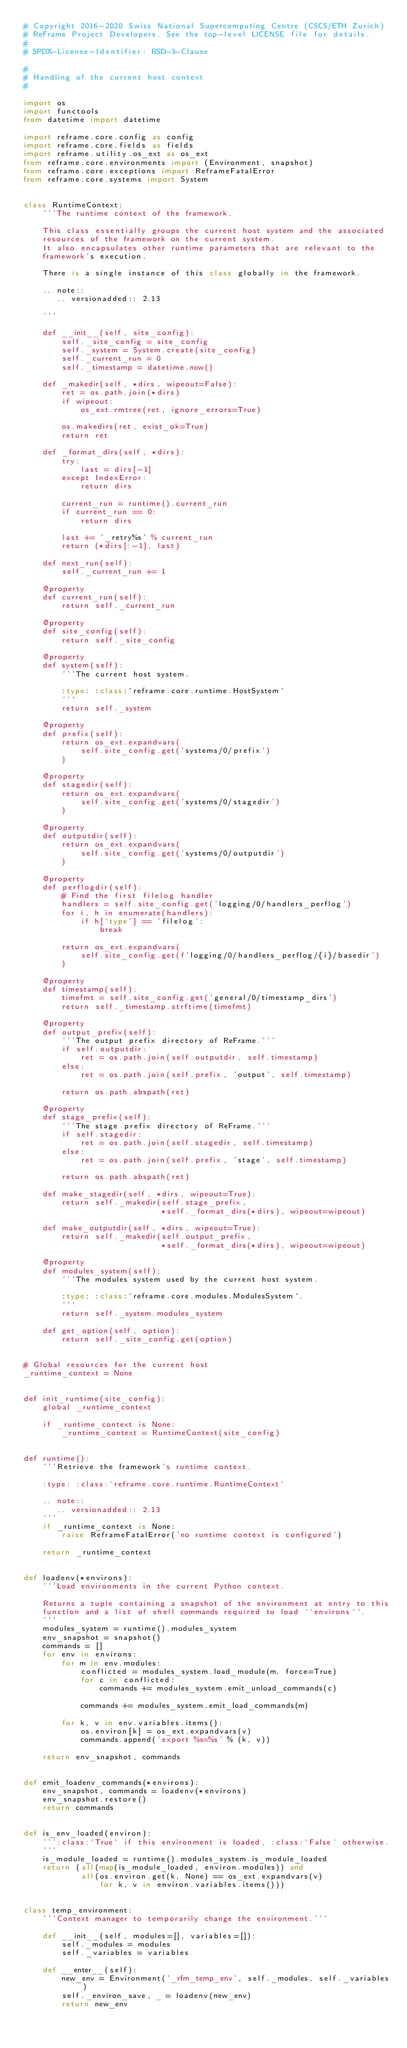<code> <loc_0><loc_0><loc_500><loc_500><_Python_># Copyright 2016-2020 Swiss National Supercomputing Centre (CSCS/ETH Zurich)
# ReFrame Project Developers. See the top-level LICENSE file for details.
#
# SPDX-License-Identifier: BSD-3-Clause

#
# Handling of the current host context
#

import os
import functools
from datetime import datetime

import reframe.core.config as config
import reframe.core.fields as fields
import reframe.utility.os_ext as os_ext
from reframe.core.environments import (Environment, snapshot)
from reframe.core.exceptions import ReframeFatalError
from reframe.core.systems import System


class RuntimeContext:
    '''The runtime context of the framework.

    This class essentially groups the current host system and the associated
    resources of the framework on the current system.
    It also encapsulates other runtime parameters that are relevant to the
    framework's execution.

    There is a single instance of this class globally in the framework.

    .. note::
       .. versionadded:: 2.13

    '''

    def __init__(self, site_config):
        self._site_config = site_config
        self._system = System.create(site_config)
        self._current_run = 0
        self._timestamp = datetime.now()

    def _makedir(self, *dirs, wipeout=False):
        ret = os.path.join(*dirs)
        if wipeout:
            os_ext.rmtree(ret, ignore_errors=True)

        os.makedirs(ret, exist_ok=True)
        return ret

    def _format_dirs(self, *dirs):
        try:
            last = dirs[-1]
        except IndexError:
            return dirs

        current_run = runtime().current_run
        if current_run == 0:
            return dirs

        last += '_retry%s' % current_run
        return (*dirs[:-1], last)

    def next_run(self):
        self._current_run += 1

    @property
    def current_run(self):
        return self._current_run

    @property
    def site_config(self):
        return self._site_config

    @property
    def system(self):
        '''The current host system.

        :type: :class:`reframe.core.runtime.HostSystem`
        '''
        return self._system

    @property
    def prefix(self):
        return os_ext.expandvars(
            self.site_config.get('systems/0/prefix')
        )

    @property
    def stagedir(self):
        return os_ext.expandvars(
            self.site_config.get('systems/0/stagedir')
        )

    @property
    def outputdir(self):
        return os_ext.expandvars(
            self.site_config.get('systems/0/outputdir')
        )

    @property
    def perflogdir(self):
        # Find the first filelog handler
        handlers = self.site_config.get('logging/0/handlers_perflog')
        for i, h in enumerate(handlers):
            if h['type'] == 'filelog':
                break

        return os_ext.expandvars(
            self.site_config.get(f'logging/0/handlers_perflog/{i}/basedir')
        )

    @property
    def timestamp(self):
        timefmt = self.site_config.get('general/0/timestamp_dirs')
        return self._timestamp.strftime(timefmt)

    @property
    def output_prefix(self):
        '''The output prefix directory of ReFrame.'''
        if self.outputdir:
            ret = os.path.join(self.outputdir, self.timestamp)
        else:
            ret = os.path.join(self.prefix, 'output', self.timestamp)

        return os.path.abspath(ret)

    @property
    def stage_prefix(self):
        '''The stage prefix directory of ReFrame.'''
        if self.stagedir:
            ret = os.path.join(self.stagedir, self.timestamp)
        else:
            ret = os.path.join(self.prefix, 'stage', self.timestamp)

        return os.path.abspath(ret)

    def make_stagedir(self, *dirs, wipeout=True):
        return self._makedir(self.stage_prefix,
                             *self._format_dirs(*dirs), wipeout=wipeout)

    def make_outputdir(self, *dirs, wipeout=True):
        return self._makedir(self.output_prefix,
                             *self._format_dirs(*dirs), wipeout=wipeout)

    @property
    def modules_system(self):
        '''The modules system used by the current host system.

        :type: :class:`reframe.core.modules.ModulesSystem`.
        '''
        return self._system.modules_system

    def get_option(self, option):
        return self._site_config.get(option)


# Global resources for the current host
_runtime_context = None


def init_runtime(site_config):
    global _runtime_context

    if _runtime_context is None:
        _runtime_context = RuntimeContext(site_config)


def runtime():
    '''Retrieve the framework's runtime context.

    :type: :class:`reframe.core.runtime.RuntimeContext`

    .. note::
       .. versionadded:: 2.13
    '''
    if _runtime_context is None:
        raise ReframeFatalError('no runtime context is configured')

    return _runtime_context


def loadenv(*environs):
    '''Load environments in the current Python context.

    Returns a tuple containing a snapshot of the environment at entry to this
    function and a list of shell commands required to load ``environs``.
    '''
    modules_system = runtime().modules_system
    env_snapshot = snapshot()
    commands = []
    for env in environs:
        for m in env.modules:
            conflicted = modules_system.load_module(m, force=True)
            for c in conflicted:
                commands += modules_system.emit_unload_commands(c)

            commands += modules_system.emit_load_commands(m)

        for k, v in env.variables.items():
            os.environ[k] = os_ext.expandvars(v)
            commands.append('export %s=%s' % (k, v))

    return env_snapshot, commands


def emit_loadenv_commands(*environs):
    env_snapshot, commands = loadenv(*environs)
    env_snapshot.restore()
    return commands


def is_env_loaded(environ):
    ''':class:`True` if this environment is loaded, :class:`False` otherwise.
    '''
    is_module_loaded = runtime().modules_system.is_module_loaded
    return (all(map(is_module_loaded, environ.modules)) and
            all(os.environ.get(k, None) == os_ext.expandvars(v)
                for k, v in environ.variables.items()))


class temp_environment:
    '''Context manager to temporarily change the environment.'''

    def __init__(self, modules=[], variables=[]):
        self._modules = modules
        self._variables = variables

    def __enter__(self):
        new_env = Environment('_rfm_temp_env', self._modules, self._variables)
        self._environ_save, _ = loadenv(new_env)
        return new_env
</code> 